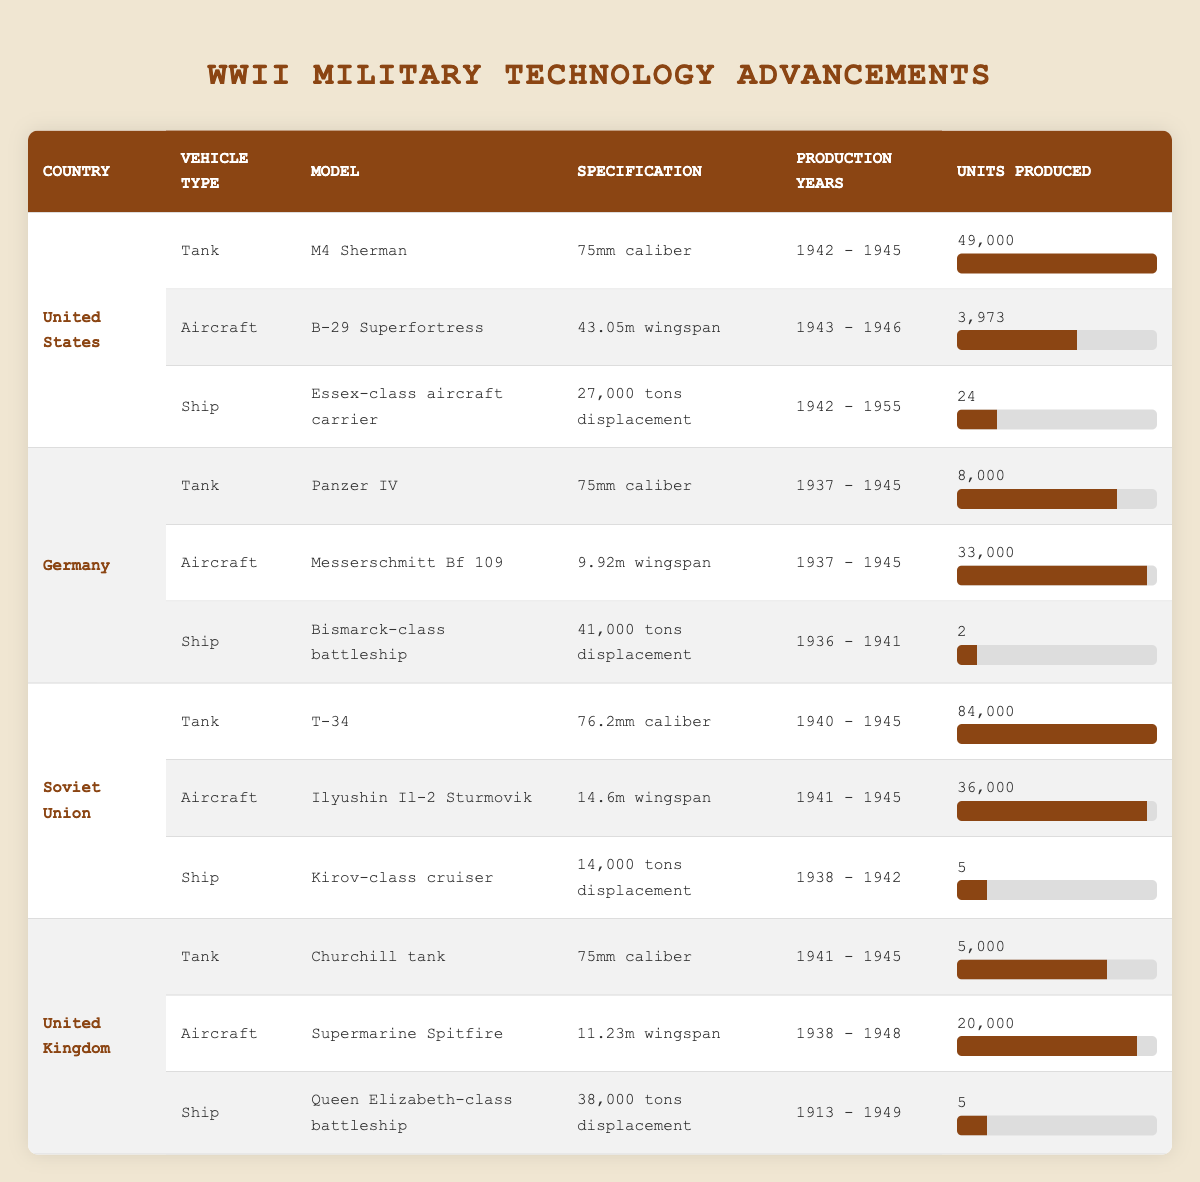What was the production year range for the M4 Sherman tank? The M4 Sherman tank was produced from 1942 to 1945, as indicated in the corresponding row of the table.
Answer: 1942 - 1945 How many units of the B-29 Superfortress were produced? The table specifies that 3,973 units of the B-29 Superfortress were produced.
Answer: 3,973 Which country produced the highest number of tanks during WWII? The Soviet Union produced the T-34 tank with 84,000 units, which is higher than the tank production of other countries listed in the table.
Answer: Soviet Union What is the difference in units produced between the Messerschmitt Bf 109 and the Panzer IV? The Messerschmitt Bf 109 had 33,000 units produced, while the Panzer IV had 8,000 units. The difference is 33,000 - 8,000 = 25,000 units.
Answer: 25,000 Did the United Kingdom produce more tanks than aircraft during WWII? The United Kingdom produced 5,000 Churchill tanks and 20,000 Supermarine Spitfires; hence, they produced more aircraft than tanks.
Answer: No Find the average number of units produced for ships among the major powers listed. The United States produced 24 Essex-class aircraft carriers, Germany 2 Bismarck-class battleships, the Soviet Union 5 Kirov-class cruisers, and the United Kingdom 5 Queen Elizabeth-class battleships. The total units produced is 24 + 2 + 5 + 5 = 36. There are 4 data points, thus the average is 36 / 4 = 9.
Answer: 9 What is the total number of units produced for tanks by the United States and the United Kingdom combined? The United States produced 49,000 M4 Shermans and the United Kingdom produced 5,000 Churchill tanks. Adding these gives a total of 49,000 + 5,000 = 54,000 units.
Answer: 54,000 Was the wingspan of the B-29 Superfortress greater than that of the Messerschmitt Bf 109? The B-29 Superfortress had a wingspan of 43.05 meters, while the Messerschmitt Bf 109's wingspan was 9.92 meters, meaning B-29 Superfortress had a greater wingspan.
Answer: Yes How many total advancements in military technology are there for Germany? Germany has three advancements: the Panzer IV tank, the Messerschmitt Bf 109 aircraft, and the Bismarck-class battleship, totaling three advancements in the table.
Answer: 3 